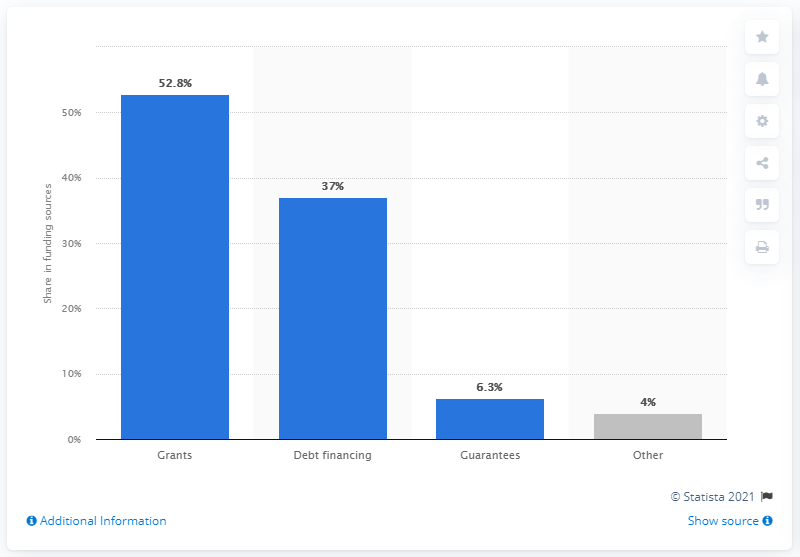Indicate a few pertinent items in this graphic. In 2015, the share of grants in the funding structure of micro-lending institutions was 52.8%. 